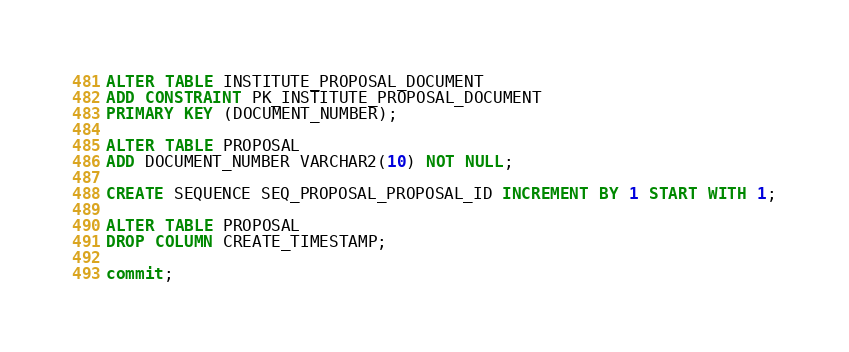<code> <loc_0><loc_0><loc_500><loc_500><_SQL_>
ALTER TABLE INSTITUTE_PROPOSAL_DOCUMENT
ADD CONSTRAINT PK_INSTITUTE_PROPOSAL_DOCUMENT
PRIMARY KEY (DOCUMENT_NUMBER);

ALTER TABLE PROPOSAL
ADD DOCUMENT_NUMBER VARCHAR2(10) NOT NULL;

CREATE SEQUENCE SEQ_PROPOSAL_PROPOSAL_ID INCREMENT BY 1 START WITH 1;

ALTER TABLE PROPOSAL
DROP COLUMN CREATE_TIMESTAMP;

commit;</code> 